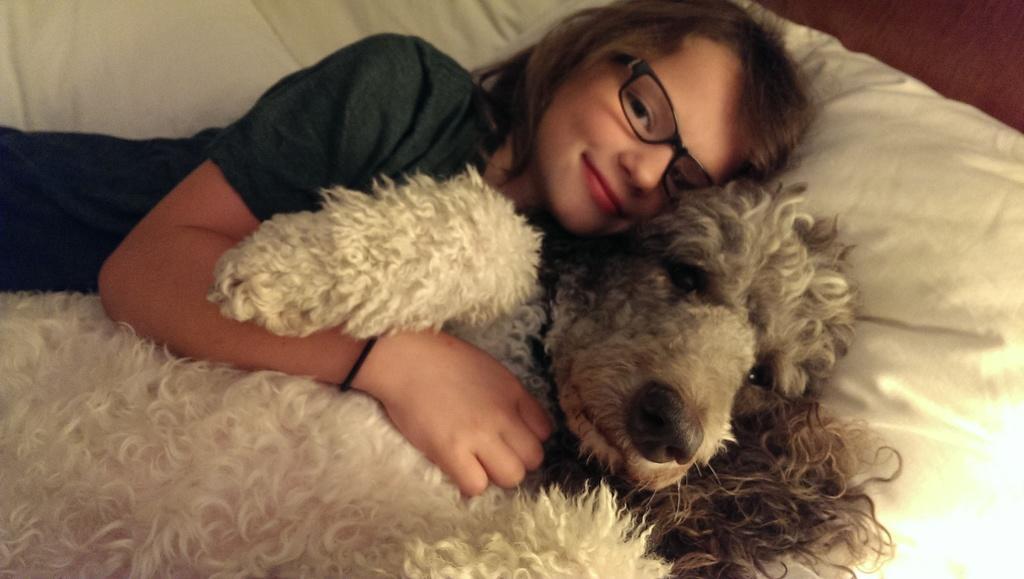Describe this image in one or two sentences. In this picture there is a girl who is wearing spectacles lying on the bed. Beside her there is a dog, lying on the bed. She is smiling. 